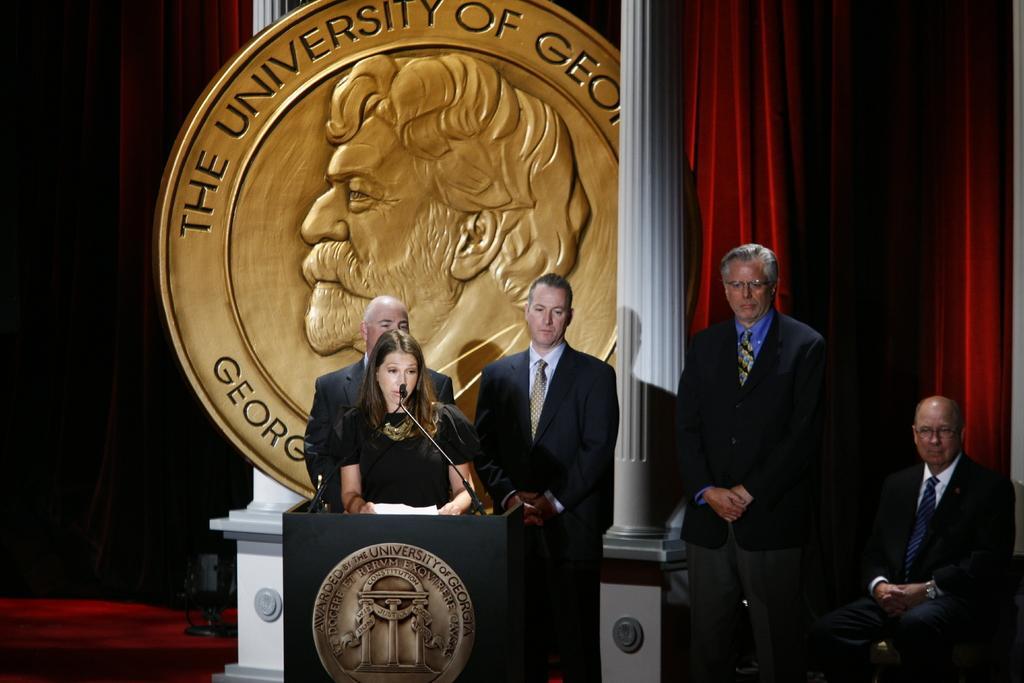Could you give a brief overview of what you see in this image? In this image we can see four persons are standing and there is a man sitting on the chair. Here we can see a mike, podium, pillars, coin, and other objects. In the background we can see curtains. 